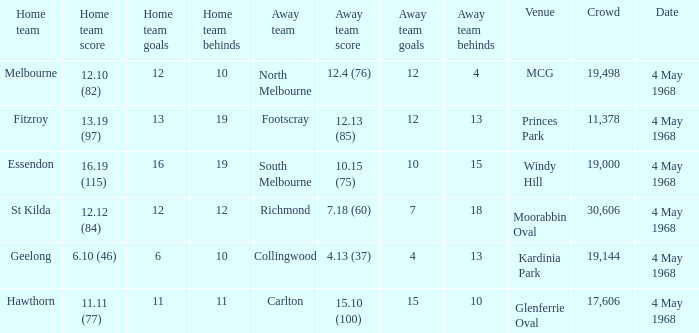What team played at Moorabbin Oval to a crowd of 19,144? St Kilda. 